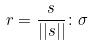<formula> <loc_0><loc_0><loc_500><loc_500>r = \frac { s } { | | s | | } \colon \sigma</formula> 